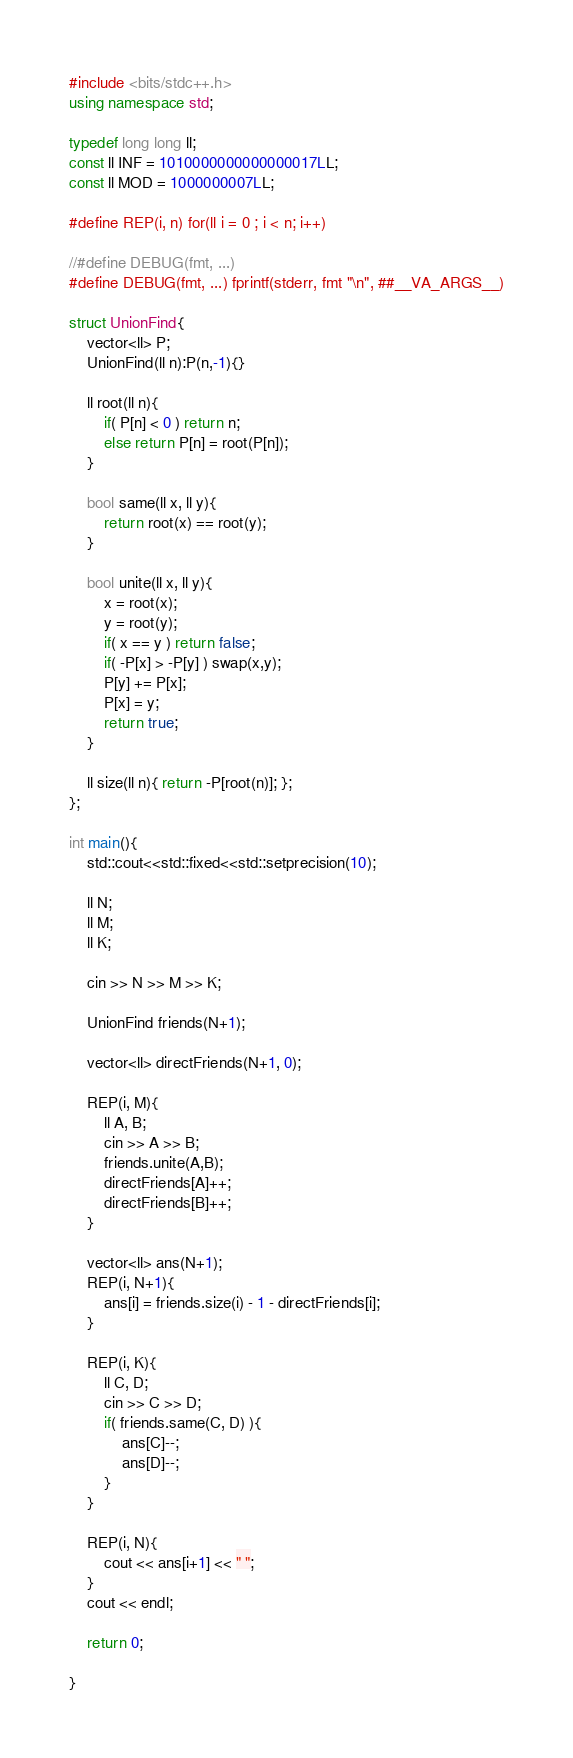<code> <loc_0><loc_0><loc_500><loc_500><_C++_>#include <bits/stdc++.h>
using namespace std;

typedef long long ll;
const ll INF = 1010000000000000017LL;
const ll MOD = 1000000007LL;

#define REP(i, n) for(ll i = 0 ; i < n; i++)

//#define DEBUG(fmt, ...)
#define DEBUG(fmt, ...) fprintf(stderr, fmt "\n", ##__VA_ARGS__)

struct UnionFind{
    vector<ll> P;
    UnionFind(ll n):P(n,-1){}

    ll root(ll n){
        if( P[n] < 0 ) return n;
        else return P[n] = root(P[n]);
    }

    bool same(ll x, ll y){
        return root(x) == root(y);
    }

    bool unite(ll x, ll y){
        x = root(x);
        y = root(y);
        if( x == y ) return false;
        if( -P[x] > -P[y] ) swap(x,y);
        P[y] += P[x];
        P[x] = y;
        return true;
    }

    ll size(ll n){ return -P[root(n)]; };
};

int main(){
    std::cout<<std::fixed<<std::setprecision(10);

    ll N;
    ll M;
    ll K;

    cin >> N >> M >> K;

    UnionFind friends(N+1);

    vector<ll> directFriends(N+1, 0);

    REP(i, M){
        ll A, B;
        cin >> A >> B;
        friends.unite(A,B);
        directFriends[A]++;
        directFriends[B]++;
    }

    vector<ll> ans(N+1);
    REP(i, N+1){
        ans[i] = friends.size(i) - 1 - directFriends[i];
    }

    REP(i, K){
        ll C, D;
        cin >> C >> D;
        if( friends.same(C, D) ){
            ans[C]--;
            ans[D]--;
        }
    }

    REP(i, N){
        cout << ans[i+1] << " ";
    }
    cout << endl;

    return 0;

}
</code> 